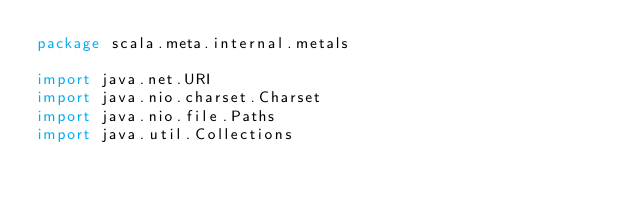Convert code to text. <code><loc_0><loc_0><loc_500><loc_500><_Scala_>package scala.meta.internal.metals

import java.net.URI
import java.nio.charset.Charset
import java.nio.file.Paths
import java.util.Collections</code> 